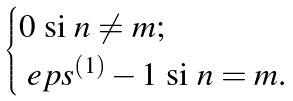<formula> <loc_0><loc_0><loc_500><loc_500>\begin{cases} 0 \text { si $n \neq m$;} \\ \ e p s ^ { ( 1 ) } - 1 \text { si $n=m$.} \end{cases}</formula> 